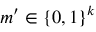<formula> <loc_0><loc_0><loc_500><loc_500>m ^ { \prime } \in \{ 0 , 1 \} ^ { k }</formula> 